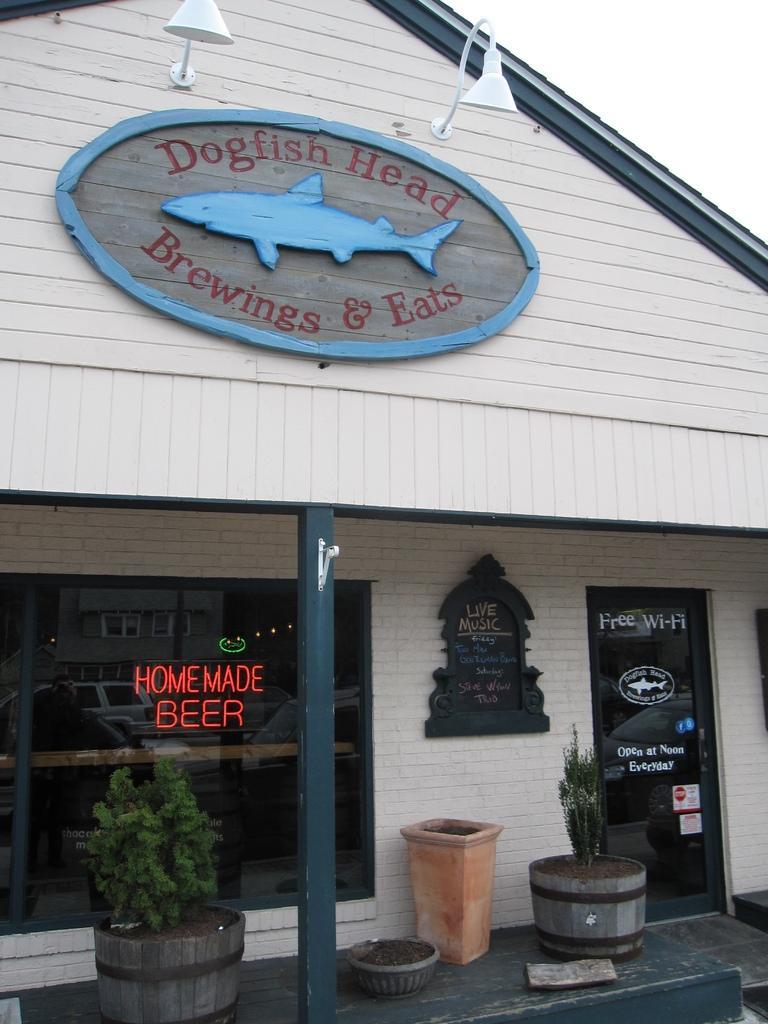Please provide a concise description of this image. In this image I can see there is a building. And there is a label with text and image of fish. And there are lights. And at the bottom there is a brick and a potted plant. And there is a sand in it. And there is a mirror with text and a door. 